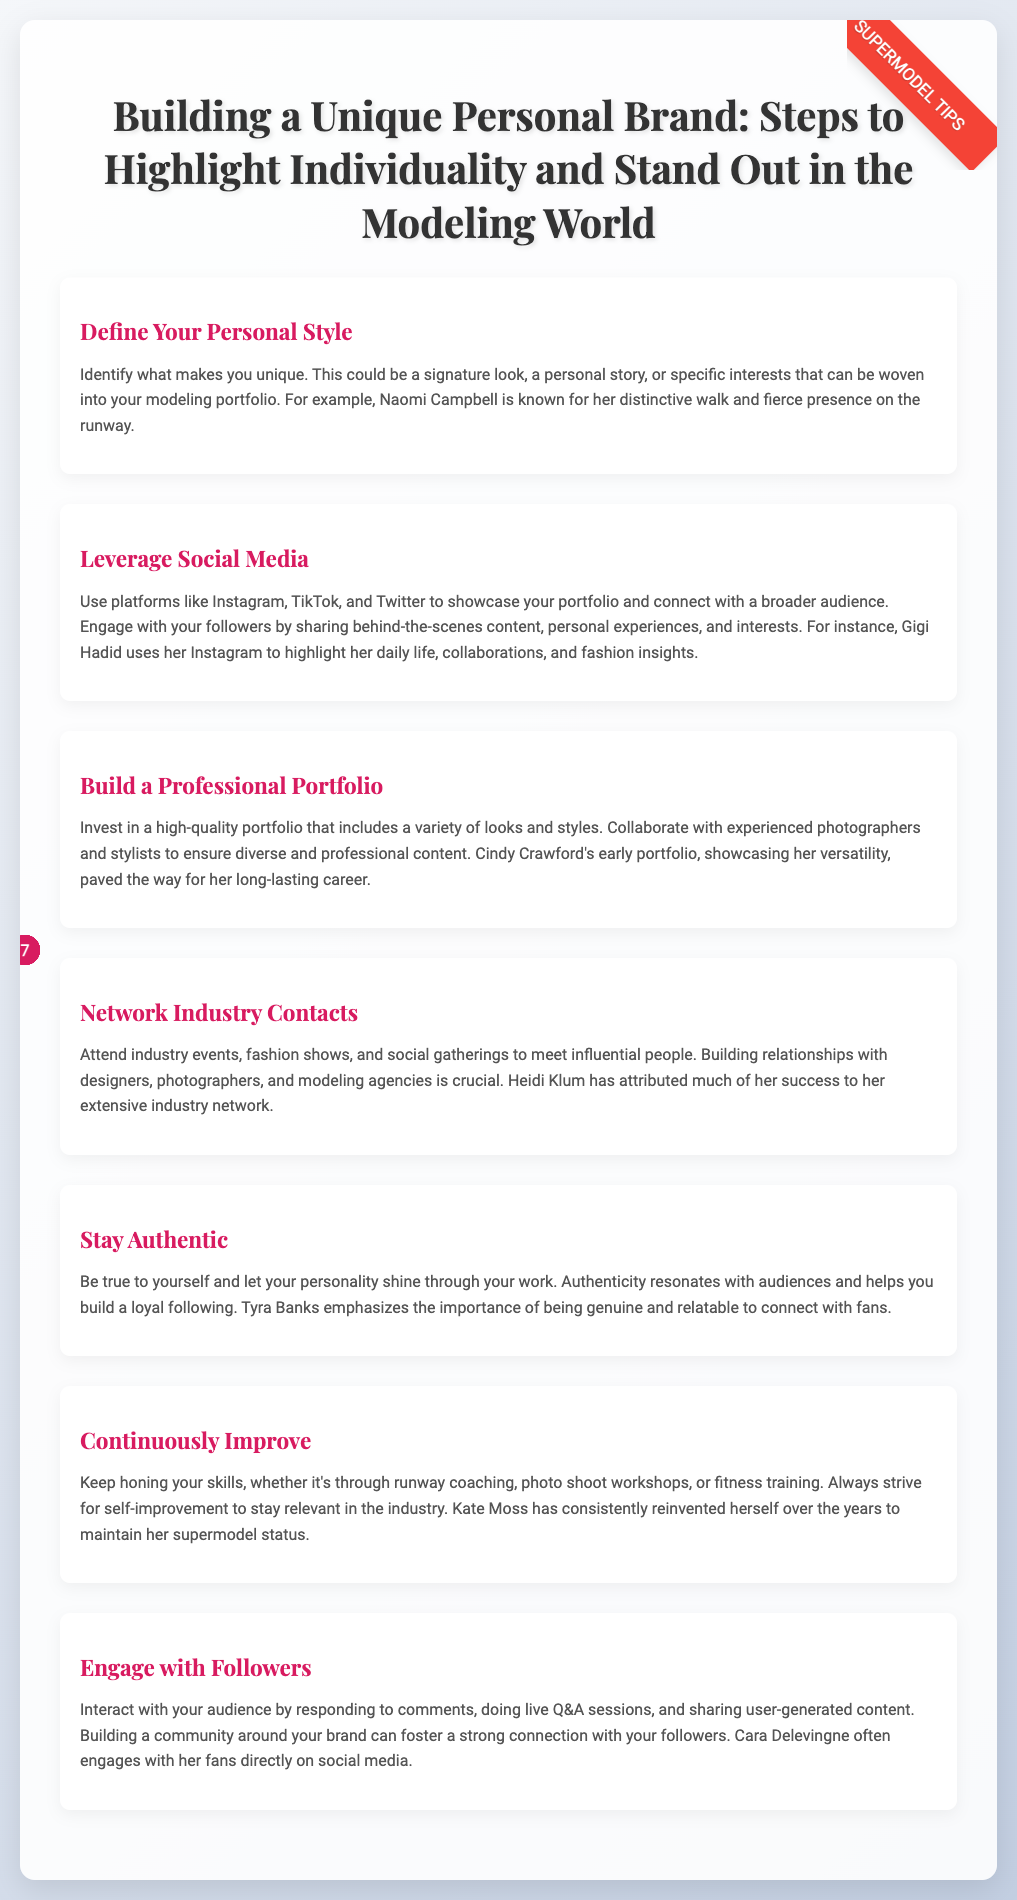what is the title of the document? The title of the document reflects the main subject it addresses, which is "Building a Unique Personal Brand: Steps to Highlight Individuality and Stand Out in the Modeling World."
Answer: Building a Unique Personal Brand: Steps to Highlight Individuality and Stand Out in the Modeling World who is known for her distinctive walk and fierce presence on the runway? The document provides an example of a model with a notable characteristic, which is Naomi Campbell known for her walk and presence.
Answer: Naomi Campbell how many steps are outlined in the document? The document lists seven distinct steps for building a personal brand, indicated by the number of items in the ordered list.
Answer: 7 which supermodel emphasizes the importance of being genuine? The document cites Tyra Banks as a supermodel who highlights the importance of authenticity.
Answer: Tyra Banks what is the first step mentioned for building a unique personal brand? The first step in the document focuses on defining one's personal style as a foundation for branding.
Answer: Define Your Personal Style how does Gigi Hadid use social media according to the document? The document states that Gigi Hadid uses social media to showcase various aspects of her life, including collaborations and fashion insights.
Answer: Highlight her daily life, collaborations, and fashion insights which supermodel has attributed much of her success to her extensive industry network? The document highlights Heidi Klum as a model who owes a significant part of her success to networking.
Answer: Heidi Klum what should you continuously strive for according to the last step? The document advises models to continuously improve their skills to remain relevant in the industry.
Answer: Self-improvement 